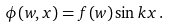<formula> <loc_0><loc_0><loc_500><loc_500>\phi ( w , x ) = f ( w ) \sin k x \, .</formula> 